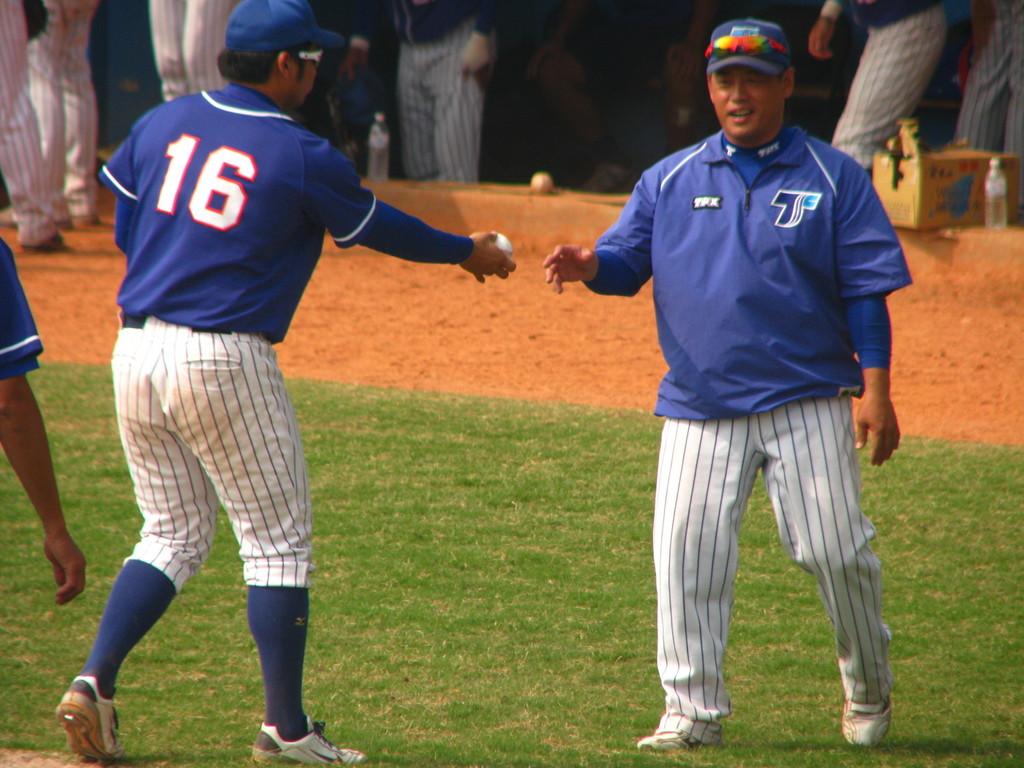What is the jersey number of the man on the left?
Offer a very short reply. 16. 